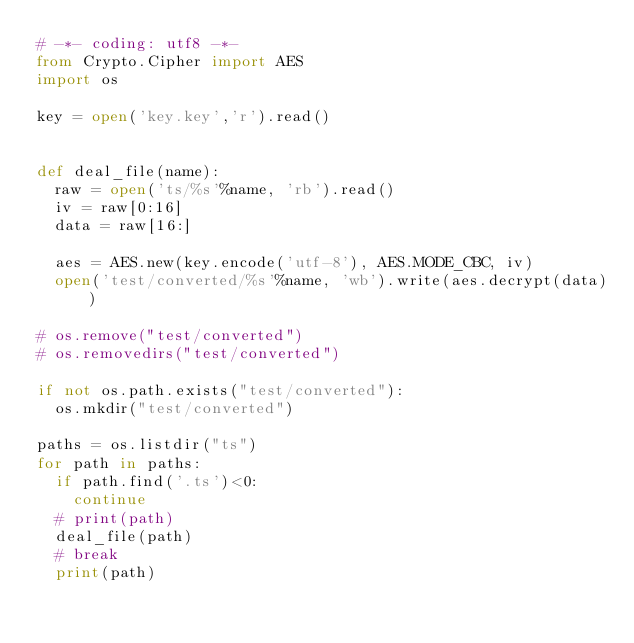<code> <loc_0><loc_0><loc_500><loc_500><_Python_># -*- coding: utf8 -*-
from Crypto.Cipher import AES
import os

key = open('key.key','r').read()


def deal_file(name):
  raw = open('ts/%s'%name, 'rb').read()
  iv = raw[0:16]
  data = raw[16:]

  aes = AES.new(key.encode('utf-8'), AES.MODE_CBC, iv)
  open('test/converted/%s'%name, 'wb').write(aes.decrypt(data))

# os.remove("test/converted")
# os.removedirs("test/converted")

if not os.path.exists("test/converted"):
  os.mkdir("test/converted")

paths = os.listdir("ts")
for path in paths:
  if path.find('.ts')<0:
    continue
  # print(path)
  deal_file(path)
  # break
  print(path)
</code> 